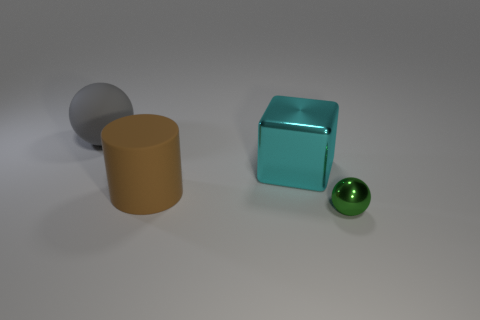Add 2 rubber things. How many objects exist? 6 Subtract all cylinders. How many objects are left? 3 Subtract all green metal spheres. Subtract all small objects. How many objects are left? 2 Add 1 cyan things. How many cyan things are left? 2 Add 1 yellow rubber blocks. How many yellow rubber blocks exist? 1 Subtract 0 cyan balls. How many objects are left? 4 